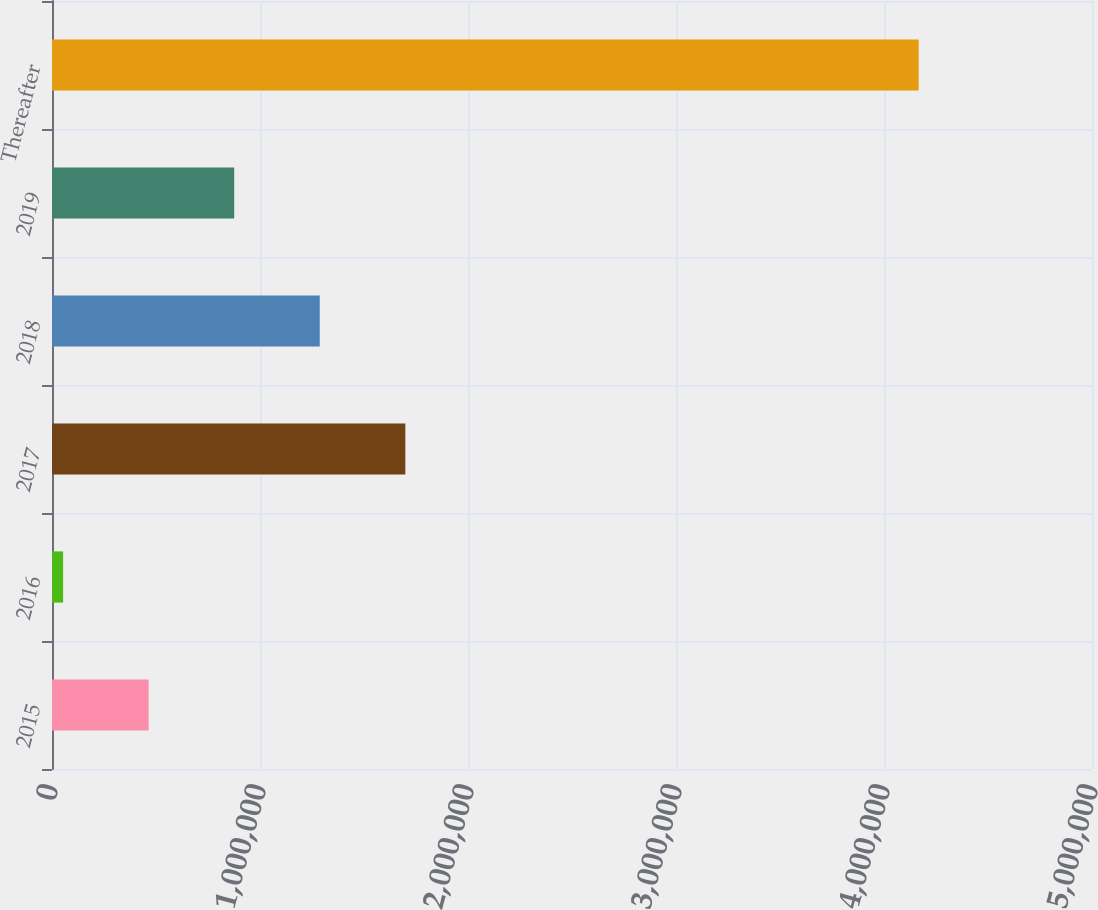<chart> <loc_0><loc_0><loc_500><loc_500><bar_chart><fcel>2015<fcel>2016<fcel>2017<fcel>2018<fcel>2019<fcel>Thereafter<nl><fcel>464679<fcel>53353<fcel>1.69866e+06<fcel>1.28733e+06<fcel>876004<fcel>4.16661e+06<nl></chart> 